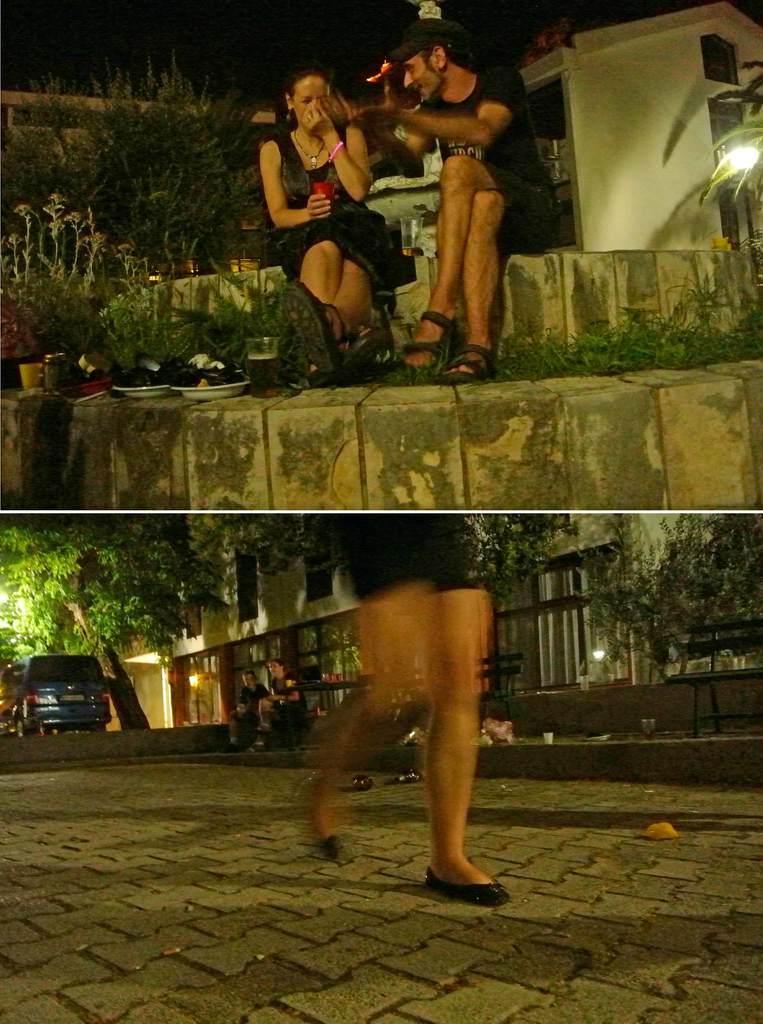Could you give a brief overview of what you see in this image? This is a photo grid image, in the top image there is a man and woman sitting on step with wine bottle and food in front of them and behind them there is a home, on the bottom image there is a woman walking on the road with a building in the back with a car and tree in front of it. 